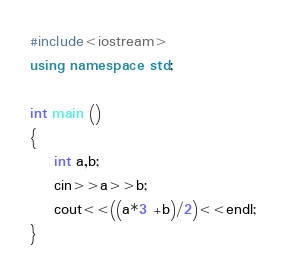<code> <loc_0><loc_0><loc_500><loc_500><_C++_>#include<iostream>
using namespace std;

int main ()
{
    int a,b;
    cin>>a>>b;
    cout<<((a*3 +b)/2)<<endl;
}
</code> 